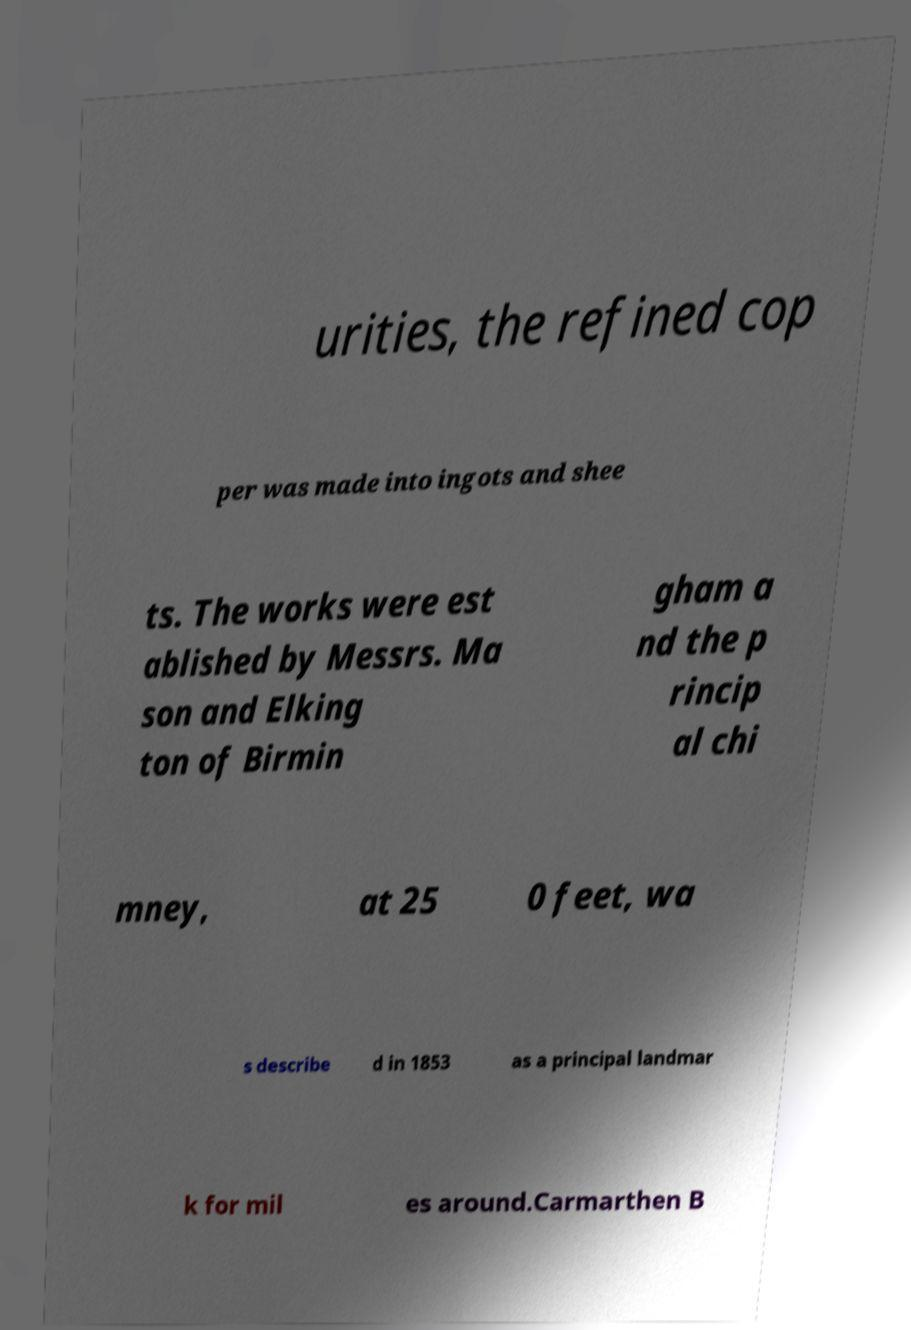For documentation purposes, I need the text within this image transcribed. Could you provide that? urities, the refined cop per was made into ingots and shee ts. The works were est ablished by Messrs. Ma son and Elking ton of Birmin gham a nd the p rincip al chi mney, at 25 0 feet, wa s describe d in 1853 as a principal landmar k for mil es around.Carmarthen B 